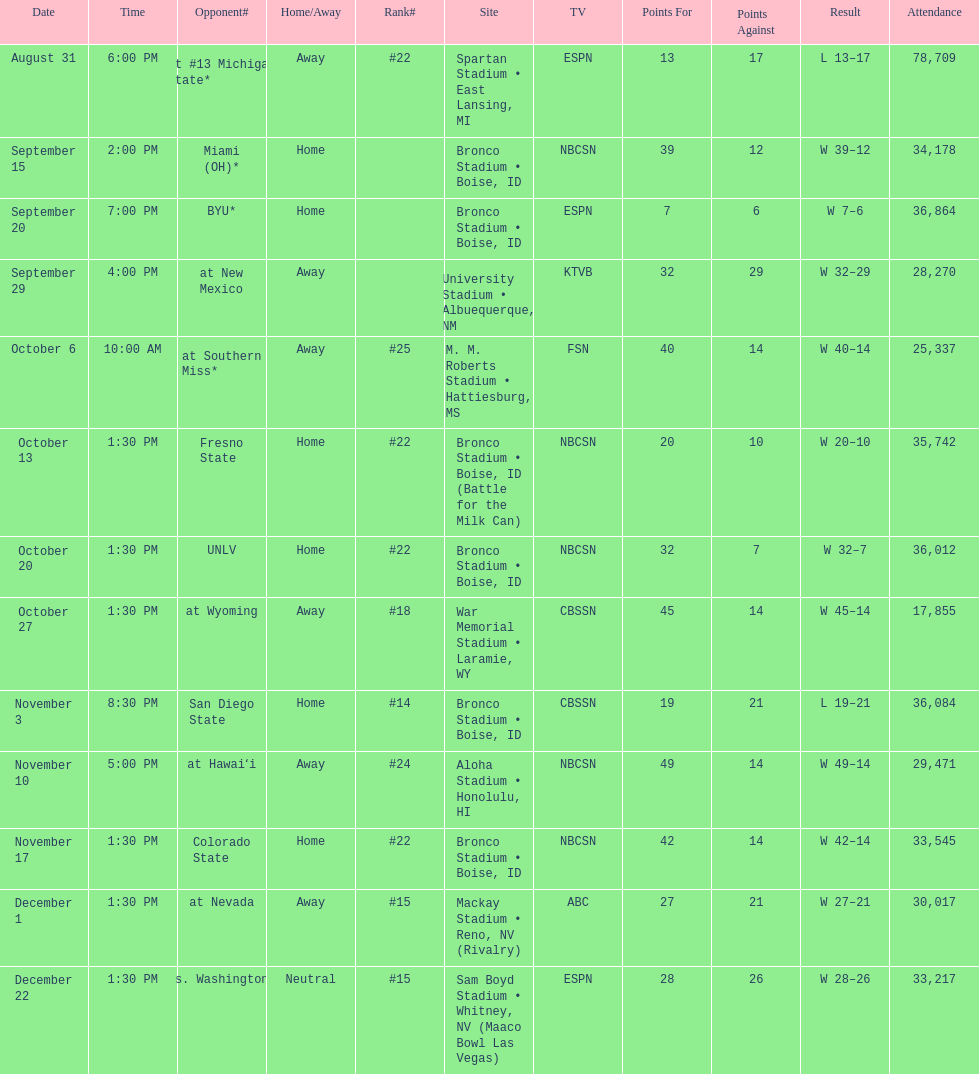What was the most consecutive wins for the team shown in the season? 7. 